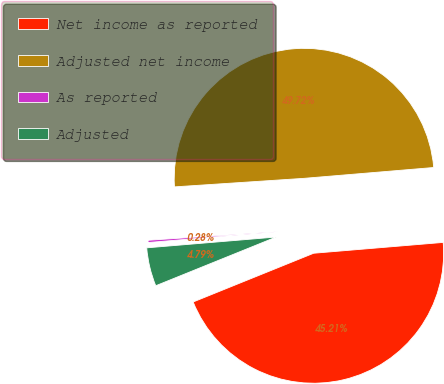Convert chart to OTSL. <chart><loc_0><loc_0><loc_500><loc_500><pie_chart><fcel>Net income as reported<fcel>Adjusted net income<fcel>As reported<fcel>Adjusted<nl><fcel>45.21%<fcel>49.72%<fcel>0.28%<fcel>4.79%<nl></chart> 